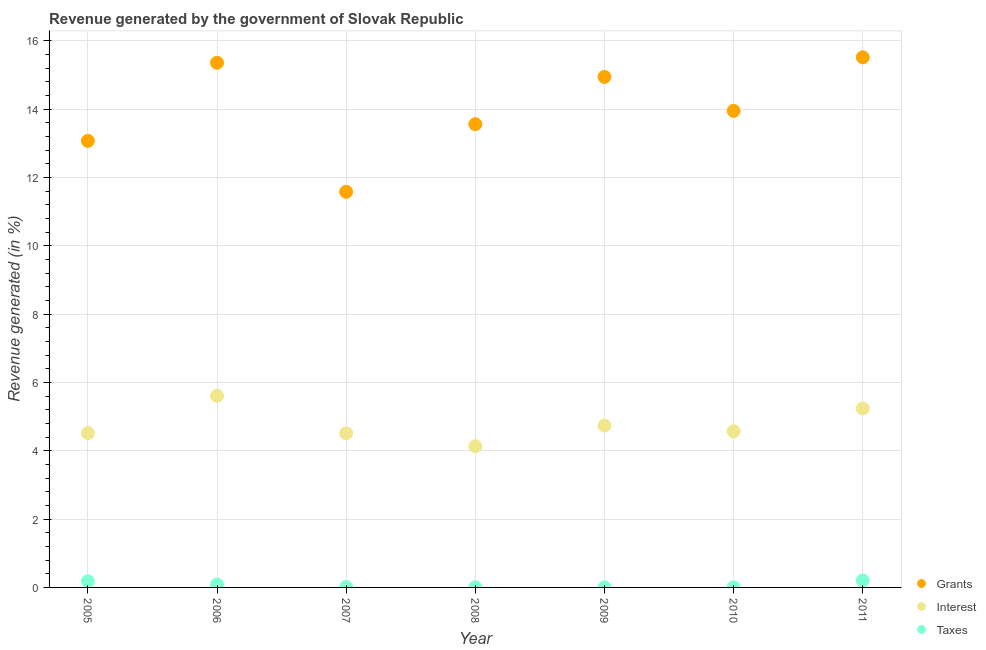How many different coloured dotlines are there?
Ensure brevity in your answer.  3. What is the percentage of revenue generated by interest in 2011?
Offer a terse response. 5.24. Across all years, what is the maximum percentage of revenue generated by interest?
Keep it short and to the point. 5.61. Across all years, what is the minimum percentage of revenue generated by grants?
Your answer should be very brief. 11.58. In which year was the percentage of revenue generated by grants maximum?
Keep it short and to the point. 2011. What is the total percentage of revenue generated by grants in the graph?
Ensure brevity in your answer.  97.99. What is the difference between the percentage of revenue generated by grants in 2007 and that in 2010?
Your response must be concise. -2.37. What is the difference between the percentage of revenue generated by grants in 2006 and the percentage of revenue generated by interest in 2005?
Offer a terse response. 10.84. What is the average percentage of revenue generated by taxes per year?
Your answer should be compact. 0.07. In the year 2006, what is the difference between the percentage of revenue generated by interest and percentage of revenue generated by grants?
Provide a succinct answer. -9.75. What is the ratio of the percentage of revenue generated by interest in 2005 to that in 2008?
Give a very brief answer. 1.09. Is the difference between the percentage of revenue generated by taxes in 2008 and 2009 greater than the difference between the percentage of revenue generated by grants in 2008 and 2009?
Your answer should be compact. Yes. What is the difference between the highest and the second highest percentage of revenue generated by grants?
Your answer should be very brief. 0.16. What is the difference between the highest and the lowest percentage of revenue generated by interest?
Keep it short and to the point. 1.48. Does the percentage of revenue generated by taxes monotonically increase over the years?
Your answer should be compact. No. Is the percentage of revenue generated by grants strictly less than the percentage of revenue generated by taxes over the years?
Provide a short and direct response. No. How many dotlines are there?
Keep it short and to the point. 3. How many years are there in the graph?
Keep it short and to the point. 7. Are the values on the major ticks of Y-axis written in scientific E-notation?
Offer a very short reply. No. Does the graph contain any zero values?
Make the answer very short. No. Does the graph contain grids?
Your answer should be very brief. Yes. Where does the legend appear in the graph?
Ensure brevity in your answer.  Bottom right. How many legend labels are there?
Ensure brevity in your answer.  3. What is the title of the graph?
Your answer should be very brief. Revenue generated by the government of Slovak Republic. What is the label or title of the X-axis?
Offer a terse response. Year. What is the label or title of the Y-axis?
Your answer should be very brief. Revenue generated (in %). What is the Revenue generated (in %) in Grants in 2005?
Offer a very short reply. 13.07. What is the Revenue generated (in %) of Interest in 2005?
Offer a terse response. 4.52. What is the Revenue generated (in %) of Taxes in 2005?
Provide a short and direct response. 0.18. What is the Revenue generated (in %) of Grants in 2006?
Make the answer very short. 15.36. What is the Revenue generated (in %) in Interest in 2006?
Keep it short and to the point. 5.61. What is the Revenue generated (in %) of Taxes in 2006?
Offer a very short reply. 0.08. What is the Revenue generated (in %) in Grants in 2007?
Provide a short and direct response. 11.58. What is the Revenue generated (in %) of Interest in 2007?
Offer a very short reply. 4.51. What is the Revenue generated (in %) in Taxes in 2007?
Your answer should be compact. 0.01. What is the Revenue generated (in %) in Grants in 2008?
Your response must be concise. 13.56. What is the Revenue generated (in %) of Interest in 2008?
Offer a terse response. 4.13. What is the Revenue generated (in %) of Taxes in 2008?
Make the answer very short. 0.01. What is the Revenue generated (in %) of Grants in 2009?
Your response must be concise. 14.94. What is the Revenue generated (in %) of Interest in 2009?
Your answer should be compact. 4.74. What is the Revenue generated (in %) in Taxes in 2009?
Ensure brevity in your answer.  0. What is the Revenue generated (in %) in Grants in 2010?
Your answer should be very brief. 13.95. What is the Revenue generated (in %) of Interest in 2010?
Offer a terse response. 4.57. What is the Revenue generated (in %) of Taxes in 2010?
Keep it short and to the point. 0. What is the Revenue generated (in %) in Grants in 2011?
Your answer should be very brief. 15.52. What is the Revenue generated (in %) in Interest in 2011?
Your answer should be compact. 5.24. What is the Revenue generated (in %) of Taxes in 2011?
Ensure brevity in your answer.  0.2. Across all years, what is the maximum Revenue generated (in %) of Grants?
Offer a terse response. 15.52. Across all years, what is the maximum Revenue generated (in %) in Interest?
Provide a short and direct response. 5.61. Across all years, what is the maximum Revenue generated (in %) in Taxes?
Keep it short and to the point. 0.2. Across all years, what is the minimum Revenue generated (in %) of Grants?
Offer a very short reply. 11.58. Across all years, what is the minimum Revenue generated (in %) in Interest?
Give a very brief answer. 4.13. Across all years, what is the minimum Revenue generated (in %) in Taxes?
Make the answer very short. 0. What is the total Revenue generated (in %) in Grants in the graph?
Your answer should be compact. 97.99. What is the total Revenue generated (in %) in Interest in the graph?
Offer a terse response. 33.32. What is the total Revenue generated (in %) of Taxes in the graph?
Provide a succinct answer. 0.49. What is the difference between the Revenue generated (in %) in Grants in 2005 and that in 2006?
Your response must be concise. -2.29. What is the difference between the Revenue generated (in %) in Interest in 2005 and that in 2006?
Keep it short and to the point. -1.09. What is the difference between the Revenue generated (in %) of Taxes in 2005 and that in 2006?
Provide a short and direct response. 0.09. What is the difference between the Revenue generated (in %) of Grants in 2005 and that in 2007?
Offer a terse response. 1.49. What is the difference between the Revenue generated (in %) of Interest in 2005 and that in 2007?
Provide a succinct answer. 0.01. What is the difference between the Revenue generated (in %) in Taxes in 2005 and that in 2007?
Provide a succinct answer. 0.16. What is the difference between the Revenue generated (in %) in Grants in 2005 and that in 2008?
Your answer should be compact. -0.49. What is the difference between the Revenue generated (in %) in Interest in 2005 and that in 2008?
Provide a short and direct response. 0.38. What is the difference between the Revenue generated (in %) of Taxes in 2005 and that in 2008?
Give a very brief answer. 0.17. What is the difference between the Revenue generated (in %) of Grants in 2005 and that in 2009?
Offer a very short reply. -1.87. What is the difference between the Revenue generated (in %) in Interest in 2005 and that in 2009?
Your answer should be very brief. -0.22. What is the difference between the Revenue generated (in %) of Taxes in 2005 and that in 2009?
Ensure brevity in your answer.  0.17. What is the difference between the Revenue generated (in %) of Grants in 2005 and that in 2010?
Provide a succinct answer. -0.88. What is the difference between the Revenue generated (in %) in Interest in 2005 and that in 2010?
Provide a short and direct response. -0.05. What is the difference between the Revenue generated (in %) in Taxes in 2005 and that in 2010?
Your response must be concise. 0.18. What is the difference between the Revenue generated (in %) in Grants in 2005 and that in 2011?
Your answer should be compact. -2.45. What is the difference between the Revenue generated (in %) in Interest in 2005 and that in 2011?
Make the answer very short. -0.72. What is the difference between the Revenue generated (in %) in Taxes in 2005 and that in 2011?
Provide a short and direct response. -0.02. What is the difference between the Revenue generated (in %) in Grants in 2006 and that in 2007?
Give a very brief answer. 3.78. What is the difference between the Revenue generated (in %) of Interest in 2006 and that in 2007?
Give a very brief answer. 1.1. What is the difference between the Revenue generated (in %) in Taxes in 2006 and that in 2007?
Offer a terse response. 0.07. What is the difference between the Revenue generated (in %) of Grants in 2006 and that in 2008?
Your answer should be very brief. 1.8. What is the difference between the Revenue generated (in %) in Interest in 2006 and that in 2008?
Your answer should be compact. 1.48. What is the difference between the Revenue generated (in %) in Taxes in 2006 and that in 2008?
Your response must be concise. 0.08. What is the difference between the Revenue generated (in %) in Grants in 2006 and that in 2009?
Your answer should be compact. 0.41. What is the difference between the Revenue generated (in %) in Interest in 2006 and that in 2009?
Make the answer very short. 0.87. What is the difference between the Revenue generated (in %) of Taxes in 2006 and that in 2009?
Provide a succinct answer. 0.08. What is the difference between the Revenue generated (in %) in Grants in 2006 and that in 2010?
Keep it short and to the point. 1.41. What is the difference between the Revenue generated (in %) of Interest in 2006 and that in 2010?
Make the answer very short. 1.04. What is the difference between the Revenue generated (in %) of Taxes in 2006 and that in 2010?
Your answer should be very brief. 0.08. What is the difference between the Revenue generated (in %) in Grants in 2006 and that in 2011?
Provide a succinct answer. -0.16. What is the difference between the Revenue generated (in %) of Interest in 2006 and that in 2011?
Your answer should be compact. 0.37. What is the difference between the Revenue generated (in %) of Taxes in 2006 and that in 2011?
Give a very brief answer. -0.12. What is the difference between the Revenue generated (in %) of Grants in 2007 and that in 2008?
Ensure brevity in your answer.  -1.98. What is the difference between the Revenue generated (in %) in Interest in 2007 and that in 2008?
Your answer should be very brief. 0.38. What is the difference between the Revenue generated (in %) in Taxes in 2007 and that in 2008?
Offer a very short reply. 0.01. What is the difference between the Revenue generated (in %) in Grants in 2007 and that in 2009?
Your answer should be compact. -3.36. What is the difference between the Revenue generated (in %) of Interest in 2007 and that in 2009?
Your answer should be very brief. -0.22. What is the difference between the Revenue generated (in %) of Taxes in 2007 and that in 2009?
Your response must be concise. 0.01. What is the difference between the Revenue generated (in %) of Grants in 2007 and that in 2010?
Give a very brief answer. -2.37. What is the difference between the Revenue generated (in %) of Interest in 2007 and that in 2010?
Your answer should be very brief. -0.06. What is the difference between the Revenue generated (in %) of Taxes in 2007 and that in 2010?
Offer a very short reply. 0.01. What is the difference between the Revenue generated (in %) in Grants in 2007 and that in 2011?
Give a very brief answer. -3.94. What is the difference between the Revenue generated (in %) in Interest in 2007 and that in 2011?
Make the answer very short. -0.73. What is the difference between the Revenue generated (in %) of Taxes in 2007 and that in 2011?
Your answer should be very brief. -0.19. What is the difference between the Revenue generated (in %) of Grants in 2008 and that in 2009?
Give a very brief answer. -1.38. What is the difference between the Revenue generated (in %) in Interest in 2008 and that in 2009?
Make the answer very short. -0.6. What is the difference between the Revenue generated (in %) in Taxes in 2008 and that in 2009?
Your answer should be very brief. 0. What is the difference between the Revenue generated (in %) in Grants in 2008 and that in 2010?
Your answer should be compact. -0.39. What is the difference between the Revenue generated (in %) of Interest in 2008 and that in 2010?
Provide a succinct answer. -0.44. What is the difference between the Revenue generated (in %) in Taxes in 2008 and that in 2010?
Provide a succinct answer. 0.01. What is the difference between the Revenue generated (in %) in Grants in 2008 and that in 2011?
Make the answer very short. -1.96. What is the difference between the Revenue generated (in %) of Interest in 2008 and that in 2011?
Offer a very short reply. -1.1. What is the difference between the Revenue generated (in %) of Taxes in 2008 and that in 2011?
Keep it short and to the point. -0.2. What is the difference between the Revenue generated (in %) of Interest in 2009 and that in 2010?
Your response must be concise. 0.16. What is the difference between the Revenue generated (in %) of Taxes in 2009 and that in 2010?
Make the answer very short. 0. What is the difference between the Revenue generated (in %) in Grants in 2009 and that in 2011?
Your answer should be compact. -0.57. What is the difference between the Revenue generated (in %) in Interest in 2009 and that in 2011?
Give a very brief answer. -0.5. What is the difference between the Revenue generated (in %) in Taxes in 2009 and that in 2011?
Give a very brief answer. -0.2. What is the difference between the Revenue generated (in %) of Grants in 2010 and that in 2011?
Your answer should be very brief. -1.57. What is the difference between the Revenue generated (in %) of Interest in 2010 and that in 2011?
Offer a very short reply. -0.67. What is the difference between the Revenue generated (in %) in Taxes in 2010 and that in 2011?
Provide a short and direct response. -0.2. What is the difference between the Revenue generated (in %) of Grants in 2005 and the Revenue generated (in %) of Interest in 2006?
Ensure brevity in your answer.  7.46. What is the difference between the Revenue generated (in %) of Grants in 2005 and the Revenue generated (in %) of Taxes in 2006?
Offer a terse response. 12.99. What is the difference between the Revenue generated (in %) of Interest in 2005 and the Revenue generated (in %) of Taxes in 2006?
Your answer should be compact. 4.43. What is the difference between the Revenue generated (in %) of Grants in 2005 and the Revenue generated (in %) of Interest in 2007?
Keep it short and to the point. 8.56. What is the difference between the Revenue generated (in %) in Grants in 2005 and the Revenue generated (in %) in Taxes in 2007?
Offer a terse response. 13.06. What is the difference between the Revenue generated (in %) of Interest in 2005 and the Revenue generated (in %) of Taxes in 2007?
Your answer should be very brief. 4.5. What is the difference between the Revenue generated (in %) in Grants in 2005 and the Revenue generated (in %) in Interest in 2008?
Offer a terse response. 8.94. What is the difference between the Revenue generated (in %) in Grants in 2005 and the Revenue generated (in %) in Taxes in 2008?
Your answer should be very brief. 13.07. What is the difference between the Revenue generated (in %) in Interest in 2005 and the Revenue generated (in %) in Taxes in 2008?
Keep it short and to the point. 4.51. What is the difference between the Revenue generated (in %) of Grants in 2005 and the Revenue generated (in %) of Interest in 2009?
Ensure brevity in your answer.  8.34. What is the difference between the Revenue generated (in %) of Grants in 2005 and the Revenue generated (in %) of Taxes in 2009?
Keep it short and to the point. 13.07. What is the difference between the Revenue generated (in %) in Interest in 2005 and the Revenue generated (in %) in Taxes in 2009?
Offer a terse response. 4.51. What is the difference between the Revenue generated (in %) of Grants in 2005 and the Revenue generated (in %) of Interest in 2010?
Your response must be concise. 8.5. What is the difference between the Revenue generated (in %) of Grants in 2005 and the Revenue generated (in %) of Taxes in 2010?
Give a very brief answer. 13.07. What is the difference between the Revenue generated (in %) in Interest in 2005 and the Revenue generated (in %) in Taxes in 2010?
Your answer should be very brief. 4.52. What is the difference between the Revenue generated (in %) of Grants in 2005 and the Revenue generated (in %) of Interest in 2011?
Your response must be concise. 7.83. What is the difference between the Revenue generated (in %) in Grants in 2005 and the Revenue generated (in %) in Taxes in 2011?
Make the answer very short. 12.87. What is the difference between the Revenue generated (in %) of Interest in 2005 and the Revenue generated (in %) of Taxes in 2011?
Offer a terse response. 4.32. What is the difference between the Revenue generated (in %) in Grants in 2006 and the Revenue generated (in %) in Interest in 2007?
Keep it short and to the point. 10.85. What is the difference between the Revenue generated (in %) in Grants in 2006 and the Revenue generated (in %) in Taxes in 2007?
Your answer should be very brief. 15.34. What is the difference between the Revenue generated (in %) of Interest in 2006 and the Revenue generated (in %) of Taxes in 2007?
Give a very brief answer. 5.6. What is the difference between the Revenue generated (in %) of Grants in 2006 and the Revenue generated (in %) of Interest in 2008?
Provide a short and direct response. 11.23. What is the difference between the Revenue generated (in %) of Grants in 2006 and the Revenue generated (in %) of Taxes in 2008?
Offer a very short reply. 15.35. What is the difference between the Revenue generated (in %) of Interest in 2006 and the Revenue generated (in %) of Taxes in 2008?
Keep it short and to the point. 5.6. What is the difference between the Revenue generated (in %) of Grants in 2006 and the Revenue generated (in %) of Interest in 2009?
Provide a short and direct response. 10.62. What is the difference between the Revenue generated (in %) of Grants in 2006 and the Revenue generated (in %) of Taxes in 2009?
Provide a short and direct response. 15.36. What is the difference between the Revenue generated (in %) in Interest in 2006 and the Revenue generated (in %) in Taxes in 2009?
Ensure brevity in your answer.  5.61. What is the difference between the Revenue generated (in %) of Grants in 2006 and the Revenue generated (in %) of Interest in 2010?
Offer a terse response. 10.79. What is the difference between the Revenue generated (in %) of Grants in 2006 and the Revenue generated (in %) of Taxes in 2010?
Your response must be concise. 15.36. What is the difference between the Revenue generated (in %) in Interest in 2006 and the Revenue generated (in %) in Taxes in 2010?
Ensure brevity in your answer.  5.61. What is the difference between the Revenue generated (in %) of Grants in 2006 and the Revenue generated (in %) of Interest in 2011?
Provide a succinct answer. 10.12. What is the difference between the Revenue generated (in %) of Grants in 2006 and the Revenue generated (in %) of Taxes in 2011?
Your answer should be compact. 15.16. What is the difference between the Revenue generated (in %) of Interest in 2006 and the Revenue generated (in %) of Taxes in 2011?
Offer a terse response. 5.41. What is the difference between the Revenue generated (in %) of Grants in 2007 and the Revenue generated (in %) of Interest in 2008?
Give a very brief answer. 7.45. What is the difference between the Revenue generated (in %) in Grants in 2007 and the Revenue generated (in %) in Taxes in 2008?
Ensure brevity in your answer.  11.58. What is the difference between the Revenue generated (in %) in Interest in 2007 and the Revenue generated (in %) in Taxes in 2008?
Keep it short and to the point. 4.5. What is the difference between the Revenue generated (in %) of Grants in 2007 and the Revenue generated (in %) of Interest in 2009?
Give a very brief answer. 6.85. What is the difference between the Revenue generated (in %) in Grants in 2007 and the Revenue generated (in %) in Taxes in 2009?
Keep it short and to the point. 11.58. What is the difference between the Revenue generated (in %) of Interest in 2007 and the Revenue generated (in %) of Taxes in 2009?
Offer a very short reply. 4.51. What is the difference between the Revenue generated (in %) in Grants in 2007 and the Revenue generated (in %) in Interest in 2010?
Give a very brief answer. 7.01. What is the difference between the Revenue generated (in %) in Grants in 2007 and the Revenue generated (in %) in Taxes in 2010?
Your answer should be very brief. 11.58. What is the difference between the Revenue generated (in %) of Interest in 2007 and the Revenue generated (in %) of Taxes in 2010?
Keep it short and to the point. 4.51. What is the difference between the Revenue generated (in %) in Grants in 2007 and the Revenue generated (in %) in Interest in 2011?
Offer a terse response. 6.34. What is the difference between the Revenue generated (in %) in Grants in 2007 and the Revenue generated (in %) in Taxes in 2011?
Keep it short and to the point. 11.38. What is the difference between the Revenue generated (in %) of Interest in 2007 and the Revenue generated (in %) of Taxes in 2011?
Your response must be concise. 4.31. What is the difference between the Revenue generated (in %) of Grants in 2008 and the Revenue generated (in %) of Interest in 2009?
Your answer should be compact. 8.82. What is the difference between the Revenue generated (in %) of Grants in 2008 and the Revenue generated (in %) of Taxes in 2009?
Ensure brevity in your answer.  13.56. What is the difference between the Revenue generated (in %) in Interest in 2008 and the Revenue generated (in %) in Taxes in 2009?
Provide a succinct answer. 4.13. What is the difference between the Revenue generated (in %) of Grants in 2008 and the Revenue generated (in %) of Interest in 2010?
Offer a terse response. 8.99. What is the difference between the Revenue generated (in %) of Grants in 2008 and the Revenue generated (in %) of Taxes in 2010?
Ensure brevity in your answer.  13.56. What is the difference between the Revenue generated (in %) of Interest in 2008 and the Revenue generated (in %) of Taxes in 2010?
Ensure brevity in your answer.  4.13. What is the difference between the Revenue generated (in %) of Grants in 2008 and the Revenue generated (in %) of Interest in 2011?
Your response must be concise. 8.32. What is the difference between the Revenue generated (in %) of Grants in 2008 and the Revenue generated (in %) of Taxes in 2011?
Offer a terse response. 13.36. What is the difference between the Revenue generated (in %) in Interest in 2008 and the Revenue generated (in %) in Taxes in 2011?
Your answer should be compact. 3.93. What is the difference between the Revenue generated (in %) of Grants in 2009 and the Revenue generated (in %) of Interest in 2010?
Offer a very short reply. 10.37. What is the difference between the Revenue generated (in %) of Grants in 2009 and the Revenue generated (in %) of Taxes in 2010?
Ensure brevity in your answer.  14.94. What is the difference between the Revenue generated (in %) in Interest in 2009 and the Revenue generated (in %) in Taxes in 2010?
Your answer should be compact. 4.74. What is the difference between the Revenue generated (in %) of Grants in 2009 and the Revenue generated (in %) of Interest in 2011?
Keep it short and to the point. 9.71. What is the difference between the Revenue generated (in %) in Grants in 2009 and the Revenue generated (in %) in Taxes in 2011?
Your response must be concise. 14.74. What is the difference between the Revenue generated (in %) of Interest in 2009 and the Revenue generated (in %) of Taxes in 2011?
Give a very brief answer. 4.53. What is the difference between the Revenue generated (in %) of Grants in 2010 and the Revenue generated (in %) of Interest in 2011?
Provide a succinct answer. 8.71. What is the difference between the Revenue generated (in %) in Grants in 2010 and the Revenue generated (in %) in Taxes in 2011?
Your response must be concise. 13.75. What is the difference between the Revenue generated (in %) of Interest in 2010 and the Revenue generated (in %) of Taxes in 2011?
Provide a short and direct response. 4.37. What is the average Revenue generated (in %) of Grants per year?
Your answer should be very brief. 14. What is the average Revenue generated (in %) of Interest per year?
Offer a very short reply. 4.76. What is the average Revenue generated (in %) in Taxes per year?
Your answer should be very brief. 0.07. In the year 2005, what is the difference between the Revenue generated (in %) of Grants and Revenue generated (in %) of Interest?
Give a very brief answer. 8.55. In the year 2005, what is the difference between the Revenue generated (in %) of Grants and Revenue generated (in %) of Taxes?
Provide a short and direct response. 12.89. In the year 2005, what is the difference between the Revenue generated (in %) of Interest and Revenue generated (in %) of Taxes?
Offer a terse response. 4.34. In the year 2006, what is the difference between the Revenue generated (in %) of Grants and Revenue generated (in %) of Interest?
Give a very brief answer. 9.75. In the year 2006, what is the difference between the Revenue generated (in %) of Grants and Revenue generated (in %) of Taxes?
Give a very brief answer. 15.28. In the year 2006, what is the difference between the Revenue generated (in %) in Interest and Revenue generated (in %) in Taxes?
Provide a succinct answer. 5.53. In the year 2007, what is the difference between the Revenue generated (in %) of Grants and Revenue generated (in %) of Interest?
Keep it short and to the point. 7.07. In the year 2007, what is the difference between the Revenue generated (in %) in Grants and Revenue generated (in %) in Taxes?
Give a very brief answer. 11.57. In the year 2007, what is the difference between the Revenue generated (in %) in Interest and Revenue generated (in %) in Taxes?
Give a very brief answer. 4.5. In the year 2008, what is the difference between the Revenue generated (in %) of Grants and Revenue generated (in %) of Interest?
Offer a terse response. 9.43. In the year 2008, what is the difference between the Revenue generated (in %) in Grants and Revenue generated (in %) in Taxes?
Your response must be concise. 13.55. In the year 2008, what is the difference between the Revenue generated (in %) in Interest and Revenue generated (in %) in Taxes?
Ensure brevity in your answer.  4.13. In the year 2009, what is the difference between the Revenue generated (in %) of Grants and Revenue generated (in %) of Interest?
Your answer should be compact. 10.21. In the year 2009, what is the difference between the Revenue generated (in %) of Grants and Revenue generated (in %) of Taxes?
Your answer should be compact. 14.94. In the year 2009, what is the difference between the Revenue generated (in %) in Interest and Revenue generated (in %) in Taxes?
Provide a succinct answer. 4.73. In the year 2010, what is the difference between the Revenue generated (in %) in Grants and Revenue generated (in %) in Interest?
Your response must be concise. 9.38. In the year 2010, what is the difference between the Revenue generated (in %) of Grants and Revenue generated (in %) of Taxes?
Give a very brief answer. 13.95. In the year 2010, what is the difference between the Revenue generated (in %) in Interest and Revenue generated (in %) in Taxes?
Keep it short and to the point. 4.57. In the year 2011, what is the difference between the Revenue generated (in %) of Grants and Revenue generated (in %) of Interest?
Keep it short and to the point. 10.28. In the year 2011, what is the difference between the Revenue generated (in %) of Grants and Revenue generated (in %) of Taxes?
Your answer should be very brief. 15.32. In the year 2011, what is the difference between the Revenue generated (in %) of Interest and Revenue generated (in %) of Taxes?
Your answer should be compact. 5.04. What is the ratio of the Revenue generated (in %) of Grants in 2005 to that in 2006?
Offer a terse response. 0.85. What is the ratio of the Revenue generated (in %) in Interest in 2005 to that in 2006?
Your answer should be very brief. 0.81. What is the ratio of the Revenue generated (in %) of Taxes in 2005 to that in 2006?
Offer a terse response. 2.13. What is the ratio of the Revenue generated (in %) in Grants in 2005 to that in 2007?
Your response must be concise. 1.13. What is the ratio of the Revenue generated (in %) in Taxes in 2005 to that in 2007?
Your answer should be very brief. 12.47. What is the ratio of the Revenue generated (in %) in Grants in 2005 to that in 2008?
Provide a succinct answer. 0.96. What is the ratio of the Revenue generated (in %) in Interest in 2005 to that in 2008?
Your answer should be compact. 1.09. What is the ratio of the Revenue generated (in %) in Taxes in 2005 to that in 2008?
Make the answer very short. 25.41. What is the ratio of the Revenue generated (in %) in Grants in 2005 to that in 2009?
Ensure brevity in your answer.  0.87. What is the ratio of the Revenue generated (in %) of Interest in 2005 to that in 2009?
Give a very brief answer. 0.95. What is the ratio of the Revenue generated (in %) in Taxes in 2005 to that in 2009?
Provide a short and direct response. 45.8. What is the ratio of the Revenue generated (in %) of Grants in 2005 to that in 2010?
Provide a short and direct response. 0.94. What is the ratio of the Revenue generated (in %) of Taxes in 2005 to that in 2010?
Provide a succinct answer. 94.22. What is the ratio of the Revenue generated (in %) in Grants in 2005 to that in 2011?
Provide a succinct answer. 0.84. What is the ratio of the Revenue generated (in %) in Interest in 2005 to that in 2011?
Keep it short and to the point. 0.86. What is the ratio of the Revenue generated (in %) of Taxes in 2005 to that in 2011?
Provide a short and direct response. 0.88. What is the ratio of the Revenue generated (in %) in Grants in 2006 to that in 2007?
Offer a terse response. 1.33. What is the ratio of the Revenue generated (in %) of Interest in 2006 to that in 2007?
Your response must be concise. 1.24. What is the ratio of the Revenue generated (in %) in Taxes in 2006 to that in 2007?
Offer a very short reply. 5.85. What is the ratio of the Revenue generated (in %) in Grants in 2006 to that in 2008?
Give a very brief answer. 1.13. What is the ratio of the Revenue generated (in %) of Interest in 2006 to that in 2008?
Provide a short and direct response. 1.36. What is the ratio of the Revenue generated (in %) of Taxes in 2006 to that in 2008?
Give a very brief answer. 11.91. What is the ratio of the Revenue generated (in %) in Grants in 2006 to that in 2009?
Your answer should be compact. 1.03. What is the ratio of the Revenue generated (in %) in Interest in 2006 to that in 2009?
Make the answer very short. 1.18. What is the ratio of the Revenue generated (in %) of Taxes in 2006 to that in 2009?
Your answer should be very brief. 21.47. What is the ratio of the Revenue generated (in %) of Grants in 2006 to that in 2010?
Provide a short and direct response. 1.1. What is the ratio of the Revenue generated (in %) of Interest in 2006 to that in 2010?
Offer a very short reply. 1.23. What is the ratio of the Revenue generated (in %) in Taxes in 2006 to that in 2010?
Keep it short and to the point. 44.17. What is the ratio of the Revenue generated (in %) in Interest in 2006 to that in 2011?
Provide a succinct answer. 1.07. What is the ratio of the Revenue generated (in %) of Taxes in 2006 to that in 2011?
Offer a very short reply. 0.41. What is the ratio of the Revenue generated (in %) in Grants in 2007 to that in 2008?
Your response must be concise. 0.85. What is the ratio of the Revenue generated (in %) in Interest in 2007 to that in 2008?
Offer a terse response. 1.09. What is the ratio of the Revenue generated (in %) of Taxes in 2007 to that in 2008?
Give a very brief answer. 2.04. What is the ratio of the Revenue generated (in %) of Grants in 2007 to that in 2009?
Provide a short and direct response. 0.78. What is the ratio of the Revenue generated (in %) of Interest in 2007 to that in 2009?
Your answer should be compact. 0.95. What is the ratio of the Revenue generated (in %) of Taxes in 2007 to that in 2009?
Give a very brief answer. 3.67. What is the ratio of the Revenue generated (in %) of Grants in 2007 to that in 2010?
Your response must be concise. 0.83. What is the ratio of the Revenue generated (in %) of Taxes in 2007 to that in 2010?
Give a very brief answer. 7.55. What is the ratio of the Revenue generated (in %) of Grants in 2007 to that in 2011?
Provide a succinct answer. 0.75. What is the ratio of the Revenue generated (in %) of Interest in 2007 to that in 2011?
Your answer should be very brief. 0.86. What is the ratio of the Revenue generated (in %) in Taxes in 2007 to that in 2011?
Your answer should be very brief. 0.07. What is the ratio of the Revenue generated (in %) in Grants in 2008 to that in 2009?
Ensure brevity in your answer.  0.91. What is the ratio of the Revenue generated (in %) in Interest in 2008 to that in 2009?
Your answer should be very brief. 0.87. What is the ratio of the Revenue generated (in %) in Taxes in 2008 to that in 2009?
Offer a very short reply. 1.8. What is the ratio of the Revenue generated (in %) in Grants in 2008 to that in 2010?
Give a very brief answer. 0.97. What is the ratio of the Revenue generated (in %) of Interest in 2008 to that in 2010?
Your answer should be very brief. 0.9. What is the ratio of the Revenue generated (in %) in Taxes in 2008 to that in 2010?
Your answer should be compact. 3.71. What is the ratio of the Revenue generated (in %) of Grants in 2008 to that in 2011?
Provide a succinct answer. 0.87. What is the ratio of the Revenue generated (in %) of Interest in 2008 to that in 2011?
Keep it short and to the point. 0.79. What is the ratio of the Revenue generated (in %) of Taxes in 2008 to that in 2011?
Provide a short and direct response. 0.03. What is the ratio of the Revenue generated (in %) in Grants in 2009 to that in 2010?
Offer a terse response. 1.07. What is the ratio of the Revenue generated (in %) in Interest in 2009 to that in 2010?
Keep it short and to the point. 1.04. What is the ratio of the Revenue generated (in %) of Taxes in 2009 to that in 2010?
Ensure brevity in your answer.  2.06. What is the ratio of the Revenue generated (in %) in Interest in 2009 to that in 2011?
Keep it short and to the point. 0.9. What is the ratio of the Revenue generated (in %) in Taxes in 2009 to that in 2011?
Offer a terse response. 0.02. What is the ratio of the Revenue generated (in %) in Grants in 2010 to that in 2011?
Your response must be concise. 0.9. What is the ratio of the Revenue generated (in %) in Interest in 2010 to that in 2011?
Your answer should be very brief. 0.87. What is the ratio of the Revenue generated (in %) of Taxes in 2010 to that in 2011?
Your answer should be very brief. 0.01. What is the difference between the highest and the second highest Revenue generated (in %) of Grants?
Give a very brief answer. 0.16. What is the difference between the highest and the second highest Revenue generated (in %) of Interest?
Make the answer very short. 0.37. What is the difference between the highest and the second highest Revenue generated (in %) in Taxes?
Your answer should be compact. 0.02. What is the difference between the highest and the lowest Revenue generated (in %) of Grants?
Provide a succinct answer. 3.94. What is the difference between the highest and the lowest Revenue generated (in %) of Interest?
Keep it short and to the point. 1.48. What is the difference between the highest and the lowest Revenue generated (in %) in Taxes?
Make the answer very short. 0.2. 